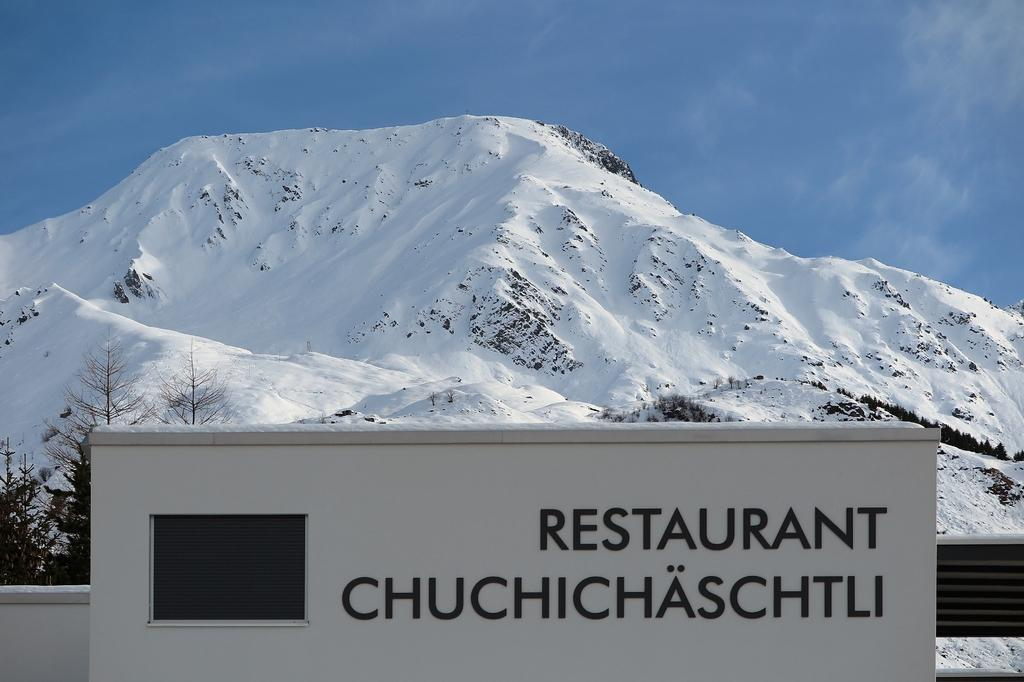<image>
Offer a succinct explanation of the picture presented. A white snow covered mountain top sits behind a sign to restaurant Chuchichaschtli. 